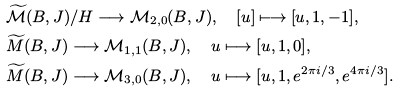<formula> <loc_0><loc_0><loc_500><loc_500>& \widetilde { \mathcal { M } } ( B , J ) / H \longrightarrow \mathcal { M } _ { 2 , 0 } ( B , J ) , \quad [ u ] \longmapsto [ u , 1 , - 1 ] , \\ & \widetilde { M } ( B , J ) \longrightarrow \mathcal { M } _ { 1 , 1 } ( B , J ) , \quad u \longmapsto [ u , 1 , 0 ] , \\ & \widetilde { M } ( B , J ) \longrightarrow \mathcal { M } _ { 3 , 0 } ( B , J ) , \quad u \longmapsto [ u , 1 , e ^ { 2 \pi i / 3 } , e ^ { 4 \pi i / 3 } ] . \\</formula> 